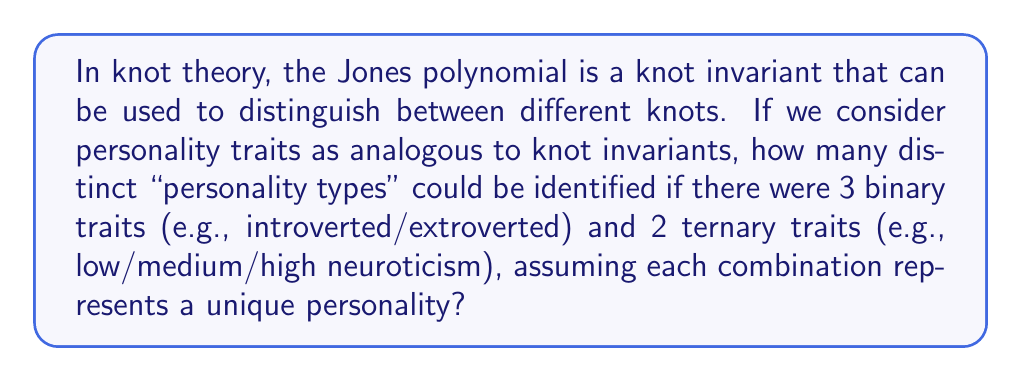Help me with this question. To solve this problem, we need to follow these steps:

1. Understand the analogy:
   - Knot invariants distinguish between knots
   - Personality traits distinguish between personalities

2. Identify the given information:
   - 3 binary traits (2 possible values each)
   - 2 ternary traits (3 possible values each)

3. Calculate the number of possible combinations:
   - For binary traits: $2^3 = 8$ combinations
   - For ternary traits: $3^2 = 9$ combinations

4. Apply the multiplication principle:
   - Total number of combinations = Binary combinations × Ternary combinations
   - $8 \times 9 = 72$

Therefore, the number of distinct "personality types" that could be identified with this set of traits is 72.

This approach is similar to how knot invariants can distinguish between different knots. Just as each combination of trait values represents a unique personality in this model, each unique polynomial or other invariant typically represents a distinct knot (or family of knots) in knot theory.
Answer: 72 